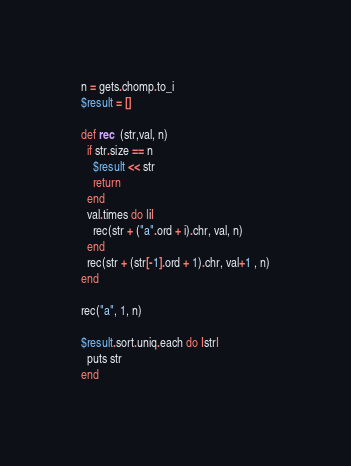<code> <loc_0><loc_0><loc_500><loc_500><_Ruby_>n = gets.chomp.to_i
$result = []

def rec  (str,val, n)
  if str.size == n
    $result << str
    return
  end
  val.times do |i|
    rec(str + ("a".ord + i).chr, val, n)
  end
  rec(str + (str[-1].ord + 1).chr, val+1 , n)
end

rec("a", 1, n)

$result.sort.uniq.each do |str|
  puts str
end</code> 